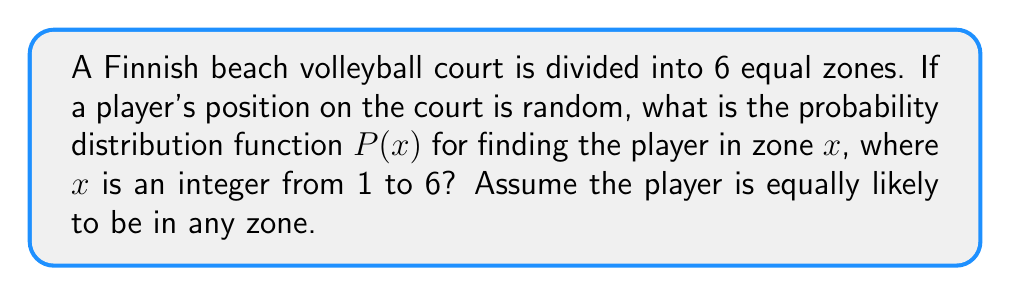Help me with this question. Let's approach this step-by-step:

1) In statistical mechanics, a uniform probability distribution is used when all outcomes are equally likely.

2) We have 6 zones, and the player is equally likely to be in any of them. This suggests a discrete uniform distribution.

3) For a discrete uniform distribution over $n$ equally likely outcomes, the probability of each outcome is $\frac{1}{n}$.

4) In this case, $n = 6$ (the number of zones).

5) Therefore, the probability of finding the player in any specific zone is $\frac{1}{6}$.

6) The probability distribution function $P(x)$ can be written as:

   $$P(x) = \begin{cases}
   \frac{1}{6} & \text{if } x \in \{1, 2, 3, 4, 5, 6\} \\
   0 & \text{otherwise}
   \end{cases}$$

7) This distribution satisfies the normalization condition:

   $$\sum_{x=1}^6 P(x) = 6 \cdot \frac{1}{6} = 1$$

8) It also satisfies the condition that probabilities are non-negative: $P(x) \geq 0$ for all $x$.
Answer: $$P(x) = \begin{cases}
\frac{1}{6} & \text{if } x \in \{1, 2, 3, 4, 5, 6\} \\
0 & \text{otherwise}
\end{cases}$$ 